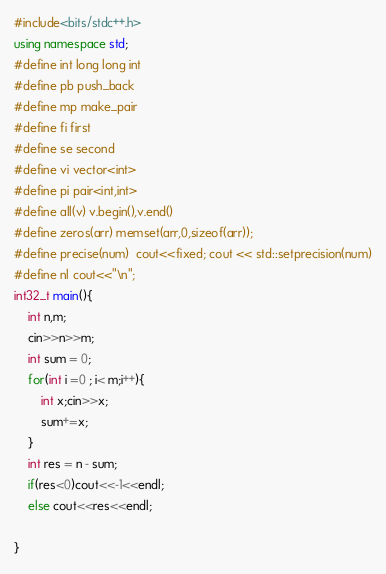Convert code to text. <code><loc_0><loc_0><loc_500><loc_500><_C++_>#include<bits/stdc++.h>
using namespace std;
#define int long long int 
#define pb push_back
#define mp make_pair
#define fi first
#define se second
#define vi vector<int>
#define pi pair<int,int>
#define all(v) v.begin(),v.end()
#define zeros(arr) memset(arr,0,sizeof(arr));
#define precise(num)  cout<<fixed; cout << std::setprecision(num)
#define nl cout<<"\n";
int32_t main(){
    int n,m;
    cin>>n>>m;
    int sum = 0;
    for(int i =0 ; i< m;i++){
        int x;cin>>x;
        sum+=x;
    }
    int res = n - sum;
    if(res<0)cout<<-1<<endl;
    else cout<<res<<endl;
    
}</code> 